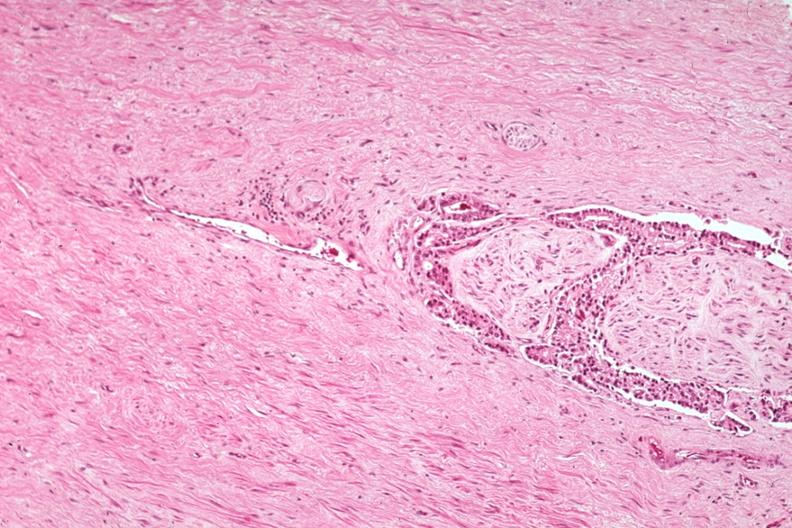s adenocarcinoma present?
Answer the question using a single word or phrase. Yes 